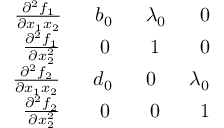<formula> <loc_0><loc_0><loc_500><loc_500>\begin{array} { r } { \frac { \partial ^ { 2 } f _ { 1 } } { \partial x _ { 1 } x _ { 2 } } \quad \ b _ { 0 } \quad \ \lambda _ { 0 } \quad \ 0 } \\ { \frac { \partial ^ { 2 } f _ { 1 } } { \partial x _ { 2 } ^ { 2 } } \quad \ \ 0 \quad \ \ 1 \quad \ \ 0 } \\ { \frac { \partial ^ { 2 } f _ { 2 } } { \partial x _ { 1 } x _ { 2 } } \quad \ d _ { 0 } \quad \ 0 \quad \ \lambda _ { 0 } } \\ { \frac { \partial ^ { 2 } f _ { 2 } } { \partial x _ { 2 } ^ { 2 } } \quad \ \ 0 \quad \ \ 0 \quad \ \ 1 } \end{array}</formula> 